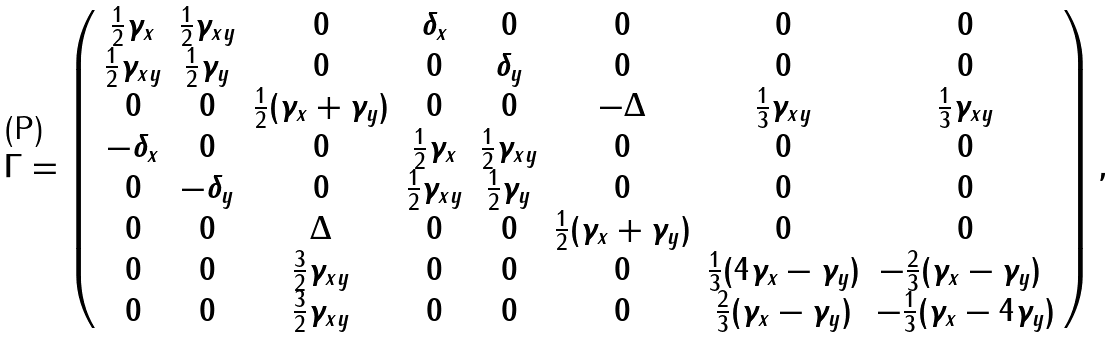<formula> <loc_0><loc_0><loc_500><loc_500>\Gamma = \left ( \begin{array} { c c c c c c c c } \frac { 1 } { 2 } \gamma _ { x } & \frac { 1 } { 2 } \gamma _ { x y } & 0 & \delta _ { x } & 0 & 0 & 0 & 0 \\ \frac { 1 } { 2 } \gamma _ { x y } & \frac { 1 } { 2 } \gamma _ { y } & 0 & 0 & \delta _ { y } & 0 & 0 & 0 \\ 0 & 0 & \frac { 1 } { 2 } ( \gamma _ { x } + \gamma _ { y } ) & 0 & 0 & - \Delta & \frac { 1 } { 3 } \gamma _ { x y } & \frac { 1 } { 3 } \gamma _ { x y } \\ - \delta _ { x } & 0 & 0 & \frac { 1 } { 2 } \gamma _ { x } & \frac { 1 } { 2 } \gamma _ { x y } & 0 & 0 & 0 \\ 0 & - \delta _ { y } & 0 & \frac { 1 } { 2 } \gamma _ { x y } & \frac { 1 } { 2 } \gamma _ { y } & 0 & 0 & 0 \\ 0 & 0 & \Delta & 0 & 0 & \frac { 1 } { 2 } ( \gamma _ { x } + \gamma _ { y } ) & 0 & 0 \\ 0 & 0 & \frac { 3 } { 2 } \gamma _ { x y } & 0 & 0 & 0 & \frac { 1 } { 3 } ( 4 \gamma _ { x } - \gamma _ { y } ) & - \frac { 2 } { 3 } ( \gamma _ { x } - \gamma _ { y } ) \ \\ 0 & 0 & \frac { 3 } { 2 } \gamma _ { x y } & 0 & 0 & 0 & \frac { 2 } { 3 } ( \gamma _ { x } - \gamma _ { y } ) & - \frac { 1 } { 3 } ( \gamma _ { x } - 4 \gamma _ { y } ) \end{array} \right ) ,</formula> 